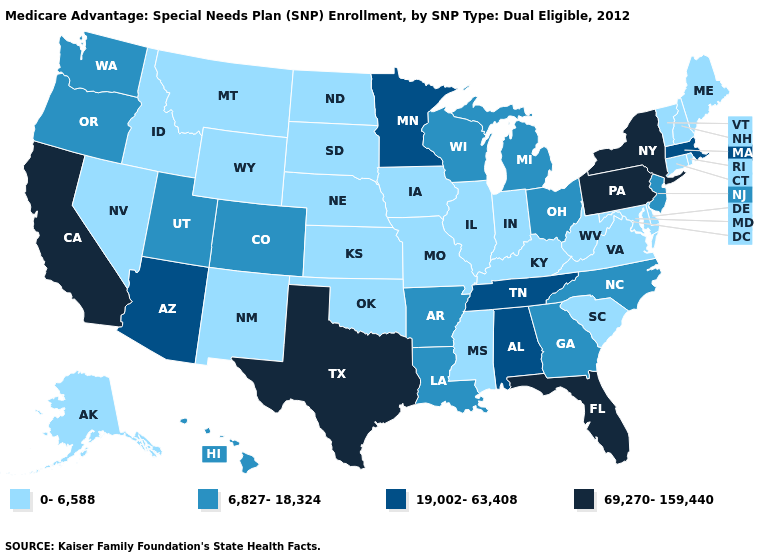Among the states that border California , which have the highest value?
Write a very short answer. Arizona. What is the value of Wisconsin?
Write a very short answer. 6,827-18,324. What is the lowest value in the USA?
Keep it brief. 0-6,588. What is the highest value in states that border North Dakota?
Quick response, please. 19,002-63,408. What is the value of Arkansas?
Write a very short answer. 6,827-18,324. What is the lowest value in the USA?
Concise answer only. 0-6,588. Name the states that have a value in the range 69,270-159,440?
Short answer required. California, Florida, New York, Pennsylvania, Texas. What is the value of Ohio?
Short answer required. 6,827-18,324. What is the value of Maryland?
Be succinct. 0-6,588. What is the value of New Jersey?
Give a very brief answer. 6,827-18,324. What is the value of North Dakota?
Answer briefly. 0-6,588. What is the value of Massachusetts?
Answer briefly. 19,002-63,408. Among the states that border Ohio , does Michigan have the lowest value?
Concise answer only. No. What is the value of Georgia?
Be succinct. 6,827-18,324. Which states have the highest value in the USA?
Give a very brief answer. California, Florida, New York, Pennsylvania, Texas. 